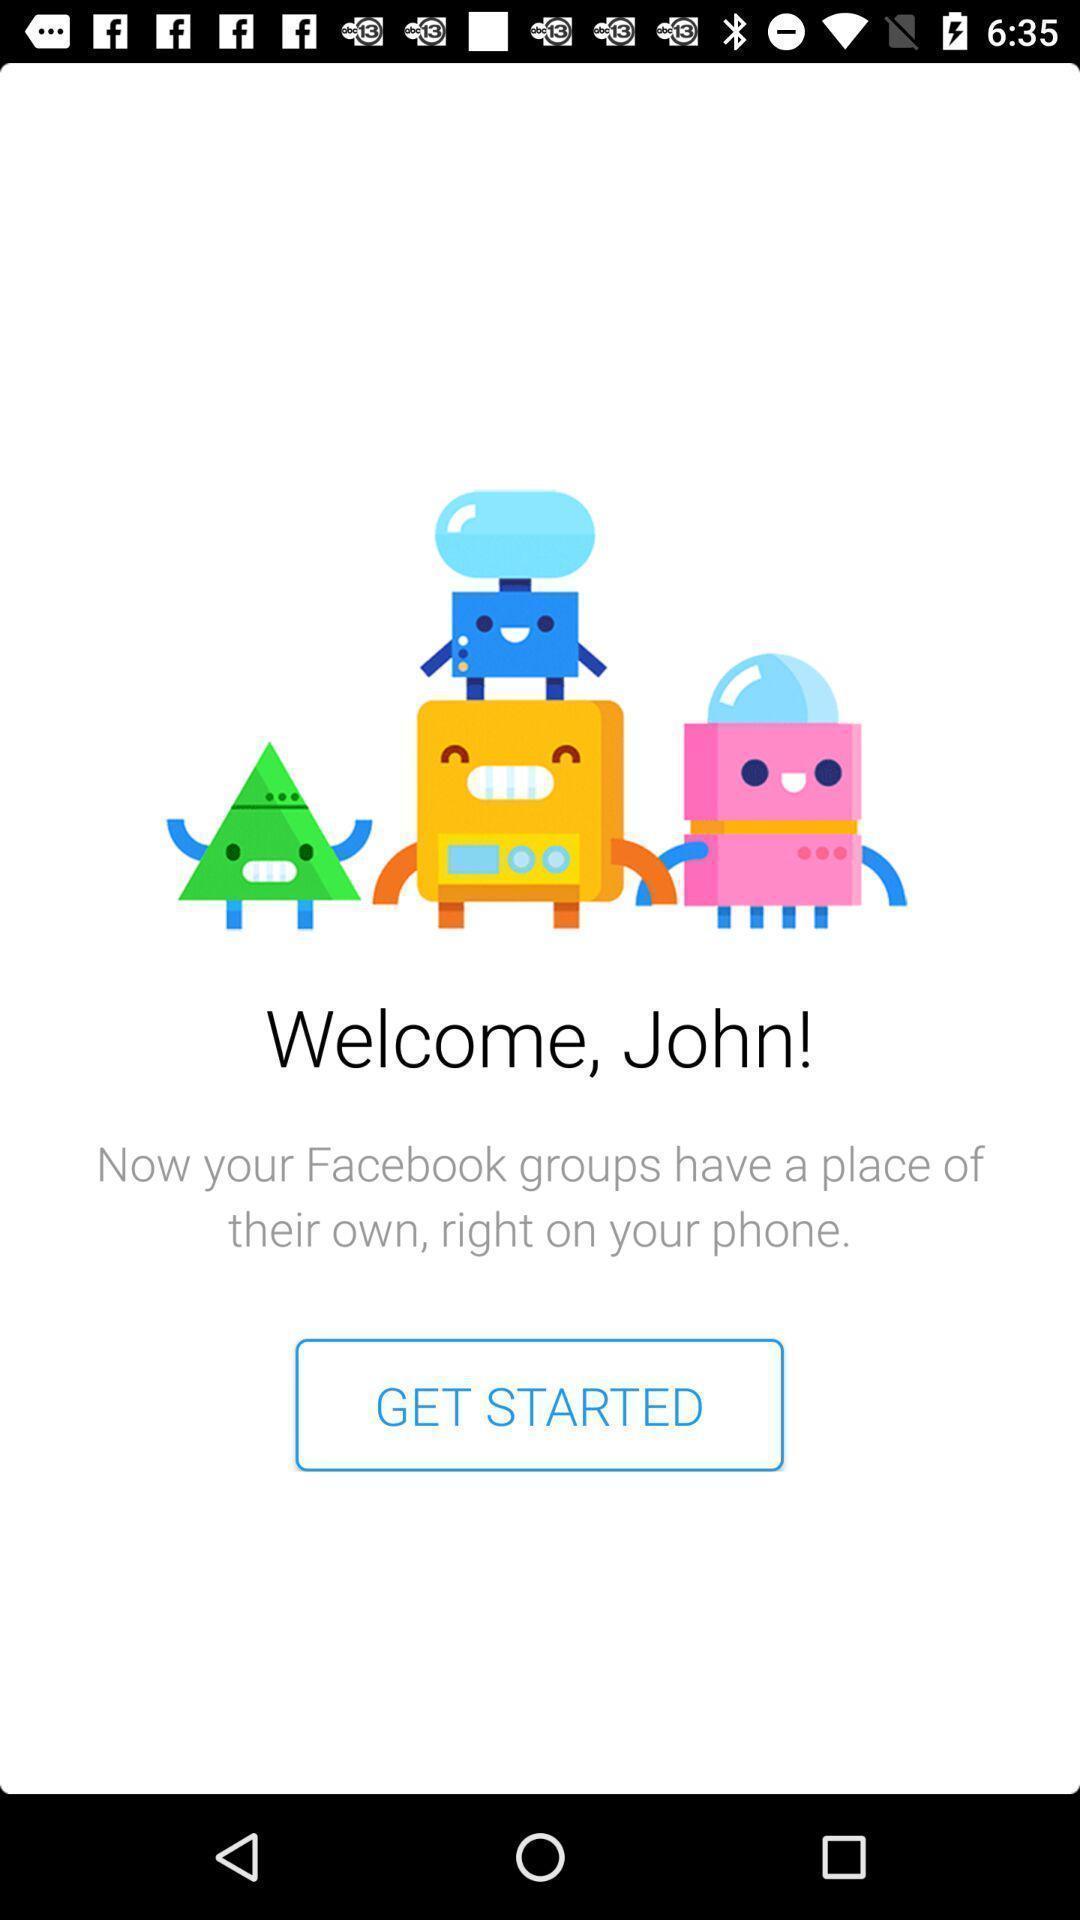Give me a narrative description of this picture. Welcome page. 